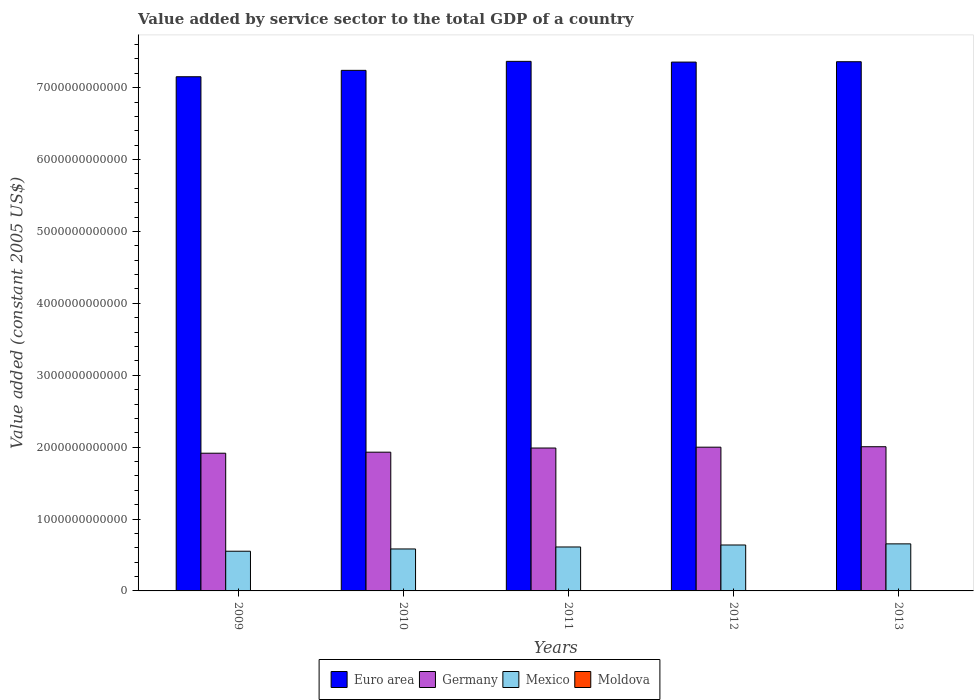How many different coloured bars are there?
Offer a very short reply. 4. How many groups of bars are there?
Your answer should be very brief. 5. How many bars are there on the 3rd tick from the left?
Ensure brevity in your answer.  4. How many bars are there on the 1st tick from the right?
Your response must be concise. 4. What is the value added by service sector in Mexico in 2013?
Keep it short and to the point. 6.54e+11. Across all years, what is the maximum value added by service sector in Germany?
Ensure brevity in your answer.  2.01e+12. Across all years, what is the minimum value added by service sector in Germany?
Offer a terse response. 1.92e+12. In which year was the value added by service sector in Moldova maximum?
Offer a very short reply. 2013. What is the total value added by service sector in Moldova in the graph?
Offer a terse response. 1.70e+1. What is the difference between the value added by service sector in Mexico in 2009 and that in 2011?
Ensure brevity in your answer.  -5.90e+1. What is the difference between the value added by service sector in Germany in 2009 and the value added by service sector in Mexico in 2013?
Keep it short and to the point. 1.26e+12. What is the average value added by service sector in Moldova per year?
Offer a very short reply. 3.40e+09. In the year 2011, what is the difference between the value added by service sector in Germany and value added by service sector in Mexico?
Offer a very short reply. 1.38e+12. What is the ratio of the value added by service sector in Euro area in 2010 to that in 2012?
Ensure brevity in your answer.  0.98. Is the difference between the value added by service sector in Germany in 2009 and 2012 greater than the difference between the value added by service sector in Mexico in 2009 and 2012?
Offer a terse response. Yes. What is the difference between the highest and the second highest value added by service sector in Euro area?
Make the answer very short. 5.09e+09. What is the difference between the highest and the lowest value added by service sector in Euro area?
Provide a succinct answer. 2.14e+11. In how many years, is the value added by service sector in Moldova greater than the average value added by service sector in Moldova taken over all years?
Provide a short and direct response. 3. Is the sum of the value added by service sector in Euro area in 2009 and 2010 greater than the maximum value added by service sector in Mexico across all years?
Provide a succinct answer. Yes. Is it the case that in every year, the sum of the value added by service sector in Mexico and value added by service sector in Moldova is greater than the sum of value added by service sector in Euro area and value added by service sector in Germany?
Your answer should be very brief. No. How many bars are there?
Offer a terse response. 20. Are all the bars in the graph horizontal?
Your response must be concise. No. What is the difference between two consecutive major ticks on the Y-axis?
Ensure brevity in your answer.  1.00e+12. Are the values on the major ticks of Y-axis written in scientific E-notation?
Keep it short and to the point. No. How many legend labels are there?
Your response must be concise. 4. What is the title of the graph?
Your answer should be compact. Value added by service sector to the total GDP of a country. Does "High income: nonOECD" appear as one of the legend labels in the graph?
Your answer should be very brief. No. What is the label or title of the X-axis?
Your answer should be compact. Years. What is the label or title of the Y-axis?
Offer a terse response. Value added (constant 2005 US$). What is the Value added (constant 2005 US$) of Euro area in 2009?
Offer a terse response. 7.15e+12. What is the Value added (constant 2005 US$) of Germany in 2009?
Offer a terse response. 1.92e+12. What is the Value added (constant 2005 US$) in Mexico in 2009?
Your answer should be compact. 5.52e+11. What is the Value added (constant 2005 US$) in Moldova in 2009?
Keep it short and to the point. 3.04e+09. What is the Value added (constant 2005 US$) in Euro area in 2010?
Provide a short and direct response. 7.24e+12. What is the Value added (constant 2005 US$) of Germany in 2010?
Offer a very short reply. 1.93e+12. What is the Value added (constant 2005 US$) in Mexico in 2010?
Your answer should be compact. 5.84e+11. What is the Value added (constant 2005 US$) in Moldova in 2010?
Provide a short and direct response. 3.20e+09. What is the Value added (constant 2005 US$) of Euro area in 2011?
Keep it short and to the point. 7.37e+12. What is the Value added (constant 2005 US$) in Germany in 2011?
Provide a succinct answer. 1.99e+12. What is the Value added (constant 2005 US$) of Mexico in 2011?
Keep it short and to the point. 6.11e+11. What is the Value added (constant 2005 US$) in Moldova in 2011?
Make the answer very short. 3.45e+09. What is the Value added (constant 2005 US$) in Euro area in 2012?
Provide a short and direct response. 7.36e+12. What is the Value added (constant 2005 US$) in Germany in 2012?
Make the answer very short. 2.00e+12. What is the Value added (constant 2005 US$) of Mexico in 2012?
Make the answer very short. 6.39e+11. What is the Value added (constant 2005 US$) of Moldova in 2012?
Make the answer very short. 3.63e+09. What is the Value added (constant 2005 US$) in Euro area in 2013?
Your response must be concise. 7.36e+12. What is the Value added (constant 2005 US$) of Germany in 2013?
Your answer should be very brief. 2.01e+12. What is the Value added (constant 2005 US$) in Mexico in 2013?
Offer a terse response. 6.54e+11. What is the Value added (constant 2005 US$) in Moldova in 2013?
Your answer should be very brief. 3.67e+09. Across all years, what is the maximum Value added (constant 2005 US$) of Euro area?
Make the answer very short. 7.37e+12. Across all years, what is the maximum Value added (constant 2005 US$) in Germany?
Provide a succinct answer. 2.01e+12. Across all years, what is the maximum Value added (constant 2005 US$) in Mexico?
Offer a very short reply. 6.54e+11. Across all years, what is the maximum Value added (constant 2005 US$) of Moldova?
Your answer should be compact. 3.67e+09. Across all years, what is the minimum Value added (constant 2005 US$) of Euro area?
Your answer should be compact. 7.15e+12. Across all years, what is the minimum Value added (constant 2005 US$) of Germany?
Provide a succinct answer. 1.92e+12. Across all years, what is the minimum Value added (constant 2005 US$) in Mexico?
Your answer should be very brief. 5.52e+11. Across all years, what is the minimum Value added (constant 2005 US$) of Moldova?
Ensure brevity in your answer.  3.04e+09. What is the total Value added (constant 2005 US$) in Euro area in the graph?
Keep it short and to the point. 3.65e+13. What is the total Value added (constant 2005 US$) of Germany in the graph?
Keep it short and to the point. 9.84e+12. What is the total Value added (constant 2005 US$) of Mexico in the graph?
Your answer should be very brief. 3.04e+12. What is the total Value added (constant 2005 US$) of Moldova in the graph?
Provide a succinct answer. 1.70e+1. What is the difference between the Value added (constant 2005 US$) of Euro area in 2009 and that in 2010?
Your answer should be very brief. -8.87e+1. What is the difference between the Value added (constant 2005 US$) of Germany in 2009 and that in 2010?
Ensure brevity in your answer.  -1.43e+1. What is the difference between the Value added (constant 2005 US$) of Mexico in 2009 and that in 2010?
Your response must be concise. -3.13e+1. What is the difference between the Value added (constant 2005 US$) in Moldova in 2009 and that in 2010?
Give a very brief answer. -1.55e+08. What is the difference between the Value added (constant 2005 US$) in Euro area in 2009 and that in 2011?
Provide a succinct answer. -2.14e+11. What is the difference between the Value added (constant 2005 US$) of Germany in 2009 and that in 2011?
Give a very brief answer. -7.21e+1. What is the difference between the Value added (constant 2005 US$) of Mexico in 2009 and that in 2011?
Provide a succinct answer. -5.90e+1. What is the difference between the Value added (constant 2005 US$) in Moldova in 2009 and that in 2011?
Offer a terse response. -4.07e+08. What is the difference between the Value added (constant 2005 US$) of Euro area in 2009 and that in 2012?
Your answer should be compact. -2.04e+11. What is the difference between the Value added (constant 2005 US$) in Germany in 2009 and that in 2012?
Provide a short and direct response. -8.38e+1. What is the difference between the Value added (constant 2005 US$) in Mexico in 2009 and that in 2012?
Keep it short and to the point. -8.66e+1. What is the difference between the Value added (constant 2005 US$) of Moldova in 2009 and that in 2012?
Offer a very short reply. -5.87e+08. What is the difference between the Value added (constant 2005 US$) of Euro area in 2009 and that in 2013?
Provide a succinct answer. -2.09e+11. What is the difference between the Value added (constant 2005 US$) of Germany in 2009 and that in 2013?
Ensure brevity in your answer.  -9.01e+1. What is the difference between the Value added (constant 2005 US$) in Mexico in 2009 and that in 2013?
Your response must be concise. -1.02e+11. What is the difference between the Value added (constant 2005 US$) in Moldova in 2009 and that in 2013?
Make the answer very short. -6.29e+08. What is the difference between the Value added (constant 2005 US$) of Euro area in 2010 and that in 2011?
Your response must be concise. -1.25e+11. What is the difference between the Value added (constant 2005 US$) in Germany in 2010 and that in 2011?
Keep it short and to the point. -5.78e+1. What is the difference between the Value added (constant 2005 US$) of Mexico in 2010 and that in 2011?
Keep it short and to the point. -2.77e+1. What is the difference between the Value added (constant 2005 US$) of Moldova in 2010 and that in 2011?
Offer a terse response. -2.52e+08. What is the difference between the Value added (constant 2005 US$) of Euro area in 2010 and that in 2012?
Your response must be concise. -1.15e+11. What is the difference between the Value added (constant 2005 US$) in Germany in 2010 and that in 2012?
Keep it short and to the point. -6.95e+1. What is the difference between the Value added (constant 2005 US$) of Mexico in 2010 and that in 2012?
Your response must be concise. -5.53e+1. What is the difference between the Value added (constant 2005 US$) of Moldova in 2010 and that in 2012?
Your response must be concise. -4.32e+08. What is the difference between the Value added (constant 2005 US$) in Euro area in 2010 and that in 2013?
Your response must be concise. -1.20e+11. What is the difference between the Value added (constant 2005 US$) of Germany in 2010 and that in 2013?
Provide a succinct answer. -7.58e+1. What is the difference between the Value added (constant 2005 US$) in Mexico in 2010 and that in 2013?
Make the answer very short. -7.09e+1. What is the difference between the Value added (constant 2005 US$) of Moldova in 2010 and that in 2013?
Provide a succinct answer. -4.74e+08. What is the difference between the Value added (constant 2005 US$) in Euro area in 2011 and that in 2012?
Provide a short and direct response. 1.02e+1. What is the difference between the Value added (constant 2005 US$) in Germany in 2011 and that in 2012?
Offer a terse response. -1.17e+1. What is the difference between the Value added (constant 2005 US$) in Mexico in 2011 and that in 2012?
Your answer should be very brief. -2.76e+1. What is the difference between the Value added (constant 2005 US$) in Moldova in 2011 and that in 2012?
Offer a terse response. -1.80e+08. What is the difference between the Value added (constant 2005 US$) in Euro area in 2011 and that in 2013?
Provide a succinct answer. 5.09e+09. What is the difference between the Value added (constant 2005 US$) in Germany in 2011 and that in 2013?
Offer a very short reply. -1.80e+1. What is the difference between the Value added (constant 2005 US$) in Mexico in 2011 and that in 2013?
Provide a succinct answer. -4.32e+1. What is the difference between the Value added (constant 2005 US$) of Moldova in 2011 and that in 2013?
Keep it short and to the point. -2.22e+08. What is the difference between the Value added (constant 2005 US$) of Euro area in 2012 and that in 2013?
Your answer should be compact. -5.07e+09. What is the difference between the Value added (constant 2005 US$) of Germany in 2012 and that in 2013?
Your answer should be very brief. -6.36e+09. What is the difference between the Value added (constant 2005 US$) of Mexico in 2012 and that in 2013?
Your response must be concise. -1.56e+1. What is the difference between the Value added (constant 2005 US$) in Moldova in 2012 and that in 2013?
Provide a succinct answer. -4.26e+07. What is the difference between the Value added (constant 2005 US$) of Euro area in 2009 and the Value added (constant 2005 US$) of Germany in 2010?
Your response must be concise. 5.22e+12. What is the difference between the Value added (constant 2005 US$) in Euro area in 2009 and the Value added (constant 2005 US$) in Mexico in 2010?
Give a very brief answer. 6.57e+12. What is the difference between the Value added (constant 2005 US$) of Euro area in 2009 and the Value added (constant 2005 US$) of Moldova in 2010?
Provide a succinct answer. 7.15e+12. What is the difference between the Value added (constant 2005 US$) in Germany in 2009 and the Value added (constant 2005 US$) in Mexico in 2010?
Your answer should be very brief. 1.33e+12. What is the difference between the Value added (constant 2005 US$) in Germany in 2009 and the Value added (constant 2005 US$) in Moldova in 2010?
Provide a succinct answer. 1.91e+12. What is the difference between the Value added (constant 2005 US$) of Mexico in 2009 and the Value added (constant 2005 US$) of Moldova in 2010?
Your response must be concise. 5.49e+11. What is the difference between the Value added (constant 2005 US$) of Euro area in 2009 and the Value added (constant 2005 US$) of Germany in 2011?
Offer a very short reply. 5.16e+12. What is the difference between the Value added (constant 2005 US$) of Euro area in 2009 and the Value added (constant 2005 US$) of Mexico in 2011?
Your answer should be very brief. 6.54e+12. What is the difference between the Value added (constant 2005 US$) in Euro area in 2009 and the Value added (constant 2005 US$) in Moldova in 2011?
Provide a succinct answer. 7.15e+12. What is the difference between the Value added (constant 2005 US$) in Germany in 2009 and the Value added (constant 2005 US$) in Mexico in 2011?
Offer a very short reply. 1.30e+12. What is the difference between the Value added (constant 2005 US$) in Germany in 2009 and the Value added (constant 2005 US$) in Moldova in 2011?
Offer a terse response. 1.91e+12. What is the difference between the Value added (constant 2005 US$) in Mexico in 2009 and the Value added (constant 2005 US$) in Moldova in 2011?
Your answer should be compact. 5.49e+11. What is the difference between the Value added (constant 2005 US$) in Euro area in 2009 and the Value added (constant 2005 US$) in Germany in 2012?
Offer a terse response. 5.15e+12. What is the difference between the Value added (constant 2005 US$) of Euro area in 2009 and the Value added (constant 2005 US$) of Mexico in 2012?
Offer a very short reply. 6.51e+12. What is the difference between the Value added (constant 2005 US$) in Euro area in 2009 and the Value added (constant 2005 US$) in Moldova in 2012?
Give a very brief answer. 7.15e+12. What is the difference between the Value added (constant 2005 US$) in Germany in 2009 and the Value added (constant 2005 US$) in Mexico in 2012?
Provide a succinct answer. 1.28e+12. What is the difference between the Value added (constant 2005 US$) of Germany in 2009 and the Value added (constant 2005 US$) of Moldova in 2012?
Your answer should be compact. 1.91e+12. What is the difference between the Value added (constant 2005 US$) in Mexico in 2009 and the Value added (constant 2005 US$) in Moldova in 2012?
Ensure brevity in your answer.  5.49e+11. What is the difference between the Value added (constant 2005 US$) in Euro area in 2009 and the Value added (constant 2005 US$) in Germany in 2013?
Keep it short and to the point. 5.15e+12. What is the difference between the Value added (constant 2005 US$) in Euro area in 2009 and the Value added (constant 2005 US$) in Mexico in 2013?
Keep it short and to the point. 6.50e+12. What is the difference between the Value added (constant 2005 US$) of Euro area in 2009 and the Value added (constant 2005 US$) of Moldova in 2013?
Provide a succinct answer. 7.15e+12. What is the difference between the Value added (constant 2005 US$) of Germany in 2009 and the Value added (constant 2005 US$) of Mexico in 2013?
Keep it short and to the point. 1.26e+12. What is the difference between the Value added (constant 2005 US$) in Germany in 2009 and the Value added (constant 2005 US$) in Moldova in 2013?
Your answer should be compact. 1.91e+12. What is the difference between the Value added (constant 2005 US$) of Mexico in 2009 and the Value added (constant 2005 US$) of Moldova in 2013?
Your answer should be compact. 5.49e+11. What is the difference between the Value added (constant 2005 US$) of Euro area in 2010 and the Value added (constant 2005 US$) of Germany in 2011?
Make the answer very short. 5.25e+12. What is the difference between the Value added (constant 2005 US$) in Euro area in 2010 and the Value added (constant 2005 US$) in Mexico in 2011?
Give a very brief answer. 6.63e+12. What is the difference between the Value added (constant 2005 US$) in Euro area in 2010 and the Value added (constant 2005 US$) in Moldova in 2011?
Provide a succinct answer. 7.24e+12. What is the difference between the Value added (constant 2005 US$) in Germany in 2010 and the Value added (constant 2005 US$) in Mexico in 2011?
Your answer should be very brief. 1.32e+12. What is the difference between the Value added (constant 2005 US$) in Germany in 2010 and the Value added (constant 2005 US$) in Moldova in 2011?
Provide a succinct answer. 1.93e+12. What is the difference between the Value added (constant 2005 US$) of Mexico in 2010 and the Value added (constant 2005 US$) of Moldova in 2011?
Give a very brief answer. 5.80e+11. What is the difference between the Value added (constant 2005 US$) in Euro area in 2010 and the Value added (constant 2005 US$) in Germany in 2012?
Give a very brief answer. 5.24e+12. What is the difference between the Value added (constant 2005 US$) of Euro area in 2010 and the Value added (constant 2005 US$) of Mexico in 2012?
Ensure brevity in your answer.  6.60e+12. What is the difference between the Value added (constant 2005 US$) of Euro area in 2010 and the Value added (constant 2005 US$) of Moldova in 2012?
Ensure brevity in your answer.  7.24e+12. What is the difference between the Value added (constant 2005 US$) in Germany in 2010 and the Value added (constant 2005 US$) in Mexico in 2012?
Provide a succinct answer. 1.29e+12. What is the difference between the Value added (constant 2005 US$) in Germany in 2010 and the Value added (constant 2005 US$) in Moldova in 2012?
Offer a very short reply. 1.93e+12. What is the difference between the Value added (constant 2005 US$) of Mexico in 2010 and the Value added (constant 2005 US$) of Moldova in 2012?
Make the answer very short. 5.80e+11. What is the difference between the Value added (constant 2005 US$) in Euro area in 2010 and the Value added (constant 2005 US$) in Germany in 2013?
Your answer should be compact. 5.24e+12. What is the difference between the Value added (constant 2005 US$) of Euro area in 2010 and the Value added (constant 2005 US$) of Mexico in 2013?
Your answer should be very brief. 6.59e+12. What is the difference between the Value added (constant 2005 US$) in Euro area in 2010 and the Value added (constant 2005 US$) in Moldova in 2013?
Provide a short and direct response. 7.24e+12. What is the difference between the Value added (constant 2005 US$) in Germany in 2010 and the Value added (constant 2005 US$) in Mexico in 2013?
Your answer should be compact. 1.28e+12. What is the difference between the Value added (constant 2005 US$) in Germany in 2010 and the Value added (constant 2005 US$) in Moldova in 2013?
Give a very brief answer. 1.93e+12. What is the difference between the Value added (constant 2005 US$) of Mexico in 2010 and the Value added (constant 2005 US$) of Moldova in 2013?
Offer a very short reply. 5.80e+11. What is the difference between the Value added (constant 2005 US$) in Euro area in 2011 and the Value added (constant 2005 US$) in Germany in 2012?
Offer a very short reply. 5.37e+12. What is the difference between the Value added (constant 2005 US$) of Euro area in 2011 and the Value added (constant 2005 US$) of Mexico in 2012?
Offer a very short reply. 6.73e+12. What is the difference between the Value added (constant 2005 US$) of Euro area in 2011 and the Value added (constant 2005 US$) of Moldova in 2012?
Offer a terse response. 7.36e+12. What is the difference between the Value added (constant 2005 US$) of Germany in 2011 and the Value added (constant 2005 US$) of Mexico in 2012?
Provide a short and direct response. 1.35e+12. What is the difference between the Value added (constant 2005 US$) in Germany in 2011 and the Value added (constant 2005 US$) in Moldova in 2012?
Offer a terse response. 1.98e+12. What is the difference between the Value added (constant 2005 US$) in Mexico in 2011 and the Value added (constant 2005 US$) in Moldova in 2012?
Provide a succinct answer. 6.08e+11. What is the difference between the Value added (constant 2005 US$) in Euro area in 2011 and the Value added (constant 2005 US$) in Germany in 2013?
Your answer should be compact. 5.36e+12. What is the difference between the Value added (constant 2005 US$) of Euro area in 2011 and the Value added (constant 2005 US$) of Mexico in 2013?
Provide a succinct answer. 6.71e+12. What is the difference between the Value added (constant 2005 US$) of Euro area in 2011 and the Value added (constant 2005 US$) of Moldova in 2013?
Ensure brevity in your answer.  7.36e+12. What is the difference between the Value added (constant 2005 US$) of Germany in 2011 and the Value added (constant 2005 US$) of Mexico in 2013?
Keep it short and to the point. 1.33e+12. What is the difference between the Value added (constant 2005 US$) of Germany in 2011 and the Value added (constant 2005 US$) of Moldova in 2013?
Offer a very short reply. 1.98e+12. What is the difference between the Value added (constant 2005 US$) of Mexico in 2011 and the Value added (constant 2005 US$) of Moldova in 2013?
Keep it short and to the point. 6.08e+11. What is the difference between the Value added (constant 2005 US$) in Euro area in 2012 and the Value added (constant 2005 US$) in Germany in 2013?
Provide a short and direct response. 5.35e+12. What is the difference between the Value added (constant 2005 US$) in Euro area in 2012 and the Value added (constant 2005 US$) in Mexico in 2013?
Ensure brevity in your answer.  6.70e+12. What is the difference between the Value added (constant 2005 US$) in Euro area in 2012 and the Value added (constant 2005 US$) in Moldova in 2013?
Provide a succinct answer. 7.35e+12. What is the difference between the Value added (constant 2005 US$) of Germany in 2012 and the Value added (constant 2005 US$) of Mexico in 2013?
Your response must be concise. 1.34e+12. What is the difference between the Value added (constant 2005 US$) in Germany in 2012 and the Value added (constant 2005 US$) in Moldova in 2013?
Provide a short and direct response. 2.00e+12. What is the difference between the Value added (constant 2005 US$) of Mexico in 2012 and the Value added (constant 2005 US$) of Moldova in 2013?
Make the answer very short. 6.35e+11. What is the average Value added (constant 2005 US$) in Euro area per year?
Provide a succinct answer. 7.30e+12. What is the average Value added (constant 2005 US$) of Germany per year?
Provide a succinct answer. 1.97e+12. What is the average Value added (constant 2005 US$) in Mexico per year?
Keep it short and to the point. 6.08e+11. What is the average Value added (constant 2005 US$) of Moldova per year?
Offer a terse response. 3.40e+09. In the year 2009, what is the difference between the Value added (constant 2005 US$) of Euro area and Value added (constant 2005 US$) of Germany?
Provide a succinct answer. 5.24e+12. In the year 2009, what is the difference between the Value added (constant 2005 US$) of Euro area and Value added (constant 2005 US$) of Mexico?
Give a very brief answer. 6.60e+12. In the year 2009, what is the difference between the Value added (constant 2005 US$) of Euro area and Value added (constant 2005 US$) of Moldova?
Your answer should be very brief. 7.15e+12. In the year 2009, what is the difference between the Value added (constant 2005 US$) of Germany and Value added (constant 2005 US$) of Mexico?
Your response must be concise. 1.36e+12. In the year 2009, what is the difference between the Value added (constant 2005 US$) of Germany and Value added (constant 2005 US$) of Moldova?
Make the answer very short. 1.91e+12. In the year 2009, what is the difference between the Value added (constant 2005 US$) in Mexico and Value added (constant 2005 US$) in Moldova?
Your response must be concise. 5.49e+11. In the year 2010, what is the difference between the Value added (constant 2005 US$) in Euro area and Value added (constant 2005 US$) in Germany?
Provide a short and direct response. 5.31e+12. In the year 2010, what is the difference between the Value added (constant 2005 US$) in Euro area and Value added (constant 2005 US$) in Mexico?
Provide a succinct answer. 6.66e+12. In the year 2010, what is the difference between the Value added (constant 2005 US$) in Euro area and Value added (constant 2005 US$) in Moldova?
Keep it short and to the point. 7.24e+12. In the year 2010, what is the difference between the Value added (constant 2005 US$) of Germany and Value added (constant 2005 US$) of Mexico?
Keep it short and to the point. 1.35e+12. In the year 2010, what is the difference between the Value added (constant 2005 US$) in Germany and Value added (constant 2005 US$) in Moldova?
Provide a succinct answer. 1.93e+12. In the year 2010, what is the difference between the Value added (constant 2005 US$) of Mexico and Value added (constant 2005 US$) of Moldova?
Offer a very short reply. 5.80e+11. In the year 2011, what is the difference between the Value added (constant 2005 US$) in Euro area and Value added (constant 2005 US$) in Germany?
Your response must be concise. 5.38e+12. In the year 2011, what is the difference between the Value added (constant 2005 US$) of Euro area and Value added (constant 2005 US$) of Mexico?
Your answer should be very brief. 6.76e+12. In the year 2011, what is the difference between the Value added (constant 2005 US$) in Euro area and Value added (constant 2005 US$) in Moldova?
Provide a short and direct response. 7.36e+12. In the year 2011, what is the difference between the Value added (constant 2005 US$) in Germany and Value added (constant 2005 US$) in Mexico?
Offer a terse response. 1.38e+12. In the year 2011, what is the difference between the Value added (constant 2005 US$) in Germany and Value added (constant 2005 US$) in Moldova?
Your response must be concise. 1.98e+12. In the year 2011, what is the difference between the Value added (constant 2005 US$) of Mexico and Value added (constant 2005 US$) of Moldova?
Provide a succinct answer. 6.08e+11. In the year 2012, what is the difference between the Value added (constant 2005 US$) of Euro area and Value added (constant 2005 US$) of Germany?
Give a very brief answer. 5.36e+12. In the year 2012, what is the difference between the Value added (constant 2005 US$) in Euro area and Value added (constant 2005 US$) in Mexico?
Give a very brief answer. 6.72e+12. In the year 2012, what is the difference between the Value added (constant 2005 US$) of Euro area and Value added (constant 2005 US$) of Moldova?
Your answer should be compact. 7.35e+12. In the year 2012, what is the difference between the Value added (constant 2005 US$) in Germany and Value added (constant 2005 US$) in Mexico?
Your answer should be compact. 1.36e+12. In the year 2012, what is the difference between the Value added (constant 2005 US$) of Germany and Value added (constant 2005 US$) of Moldova?
Keep it short and to the point. 2.00e+12. In the year 2012, what is the difference between the Value added (constant 2005 US$) of Mexico and Value added (constant 2005 US$) of Moldova?
Make the answer very short. 6.35e+11. In the year 2013, what is the difference between the Value added (constant 2005 US$) of Euro area and Value added (constant 2005 US$) of Germany?
Your response must be concise. 5.36e+12. In the year 2013, what is the difference between the Value added (constant 2005 US$) in Euro area and Value added (constant 2005 US$) in Mexico?
Offer a very short reply. 6.71e+12. In the year 2013, what is the difference between the Value added (constant 2005 US$) of Euro area and Value added (constant 2005 US$) of Moldova?
Make the answer very short. 7.36e+12. In the year 2013, what is the difference between the Value added (constant 2005 US$) in Germany and Value added (constant 2005 US$) in Mexico?
Give a very brief answer. 1.35e+12. In the year 2013, what is the difference between the Value added (constant 2005 US$) of Germany and Value added (constant 2005 US$) of Moldova?
Keep it short and to the point. 2.00e+12. In the year 2013, what is the difference between the Value added (constant 2005 US$) of Mexico and Value added (constant 2005 US$) of Moldova?
Provide a short and direct response. 6.51e+11. What is the ratio of the Value added (constant 2005 US$) of Euro area in 2009 to that in 2010?
Ensure brevity in your answer.  0.99. What is the ratio of the Value added (constant 2005 US$) in Germany in 2009 to that in 2010?
Provide a short and direct response. 0.99. What is the ratio of the Value added (constant 2005 US$) in Mexico in 2009 to that in 2010?
Ensure brevity in your answer.  0.95. What is the ratio of the Value added (constant 2005 US$) of Moldova in 2009 to that in 2010?
Your answer should be very brief. 0.95. What is the ratio of the Value added (constant 2005 US$) in Euro area in 2009 to that in 2011?
Give a very brief answer. 0.97. What is the ratio of the Value added (constant 2005 US$) in Germany in 2009 to that in 2011?
Keep it short and to the point. 0.96. What is the ratio of the Value added (constant 2005 US$) in Mexico in 2009 to that in 2011?
Offer a terse response. 0.9. What is the ratio of the Value added (constant 2005 US$) of Moldova in 2009 to that in 2011?
Your answer should be compact. 0.88. What is the ratio of the Value added (constant 2005 US$) of Euro area in 2009 to that in 2012?
Ensure brevity in your answer.  0.97. What is the ratio of the Value added (constant 2005 US$) of Germany in 2009 to that in 2012?
Offer a terse response. 0.96. What is the ratio of the Value added (constant 2005 US$) of Mexico in 2009 to that in 2012?
Your response must be concise. 0.86. What is the ratio of the Value added (constant 2005 US$) in Moldova in 2009 to that in 2012?
Give a very brief answer. 0.84. What is the ratio of the Value added (constant 2005 US$) of Euro area in 2009 to that in 2013?
Offer a very short reply. 0.97. What is the ratio of the Value added (constant 2005 US$) in Germany in 2009 to that in 2013?
Provide a succinct answer. 0.96. What is the ratio of the Value added (constant 2005 US$) in Mexico in 2009 to that in 2013?
Offer a very short reply. 0.84. What is the ratio of the Value added (constant 2005 US$) of Moldova in 2009 to that in 2013?
Ensure brevity in your answer.  0.83. What is the ratio of the Value added (constant 2005 US$) of Euro area in 2010 to that in 2011?
Your answer should be very brief. 0.98. What is the ratio of the Value added (constant 2005 US$) of Germany in 2010 to that in 2011?
Keep it short and to the point. 0.97. What is the ratio of the Value added (constant 2005 US$) in Mexico in 2010 to that in 2011?
Ensure brevity in your answer.  0.95. What is the ratio of the Value added (constant 2005 US$) of Moldova in 2010 to that in 2011?
Make the answer very short. 0.93. What is the ratio of the Value added (constant 2005 US$) in Euro area in 2010 to that in 2012?
Ensure brevity in your answer.  0.98. What is the ratio of the Value added (constant 2005 US$) in Germany in 2010 to that in 2012?
Keep it short and to the point. 0.97. What is the ratio of the Value added (constant 2005 US$) of Mexico in 2010 to that in 2012?
Keep it short and to the point. 0.91. What is the ratio of the Value added (constant 2005 US$) in Moldova in 2010 to that in 2012?
Ensure brevity in your answer.  0.88. What is the ratio of the Value added (constant 2005 US$) in Euro area in 2010 to that in 2013?
Your answer should be compact. 0.98. What is the ratio of the Value added (constant 2005 US$) in Germany in 2010 to that in 2013?
Ensure brevity in your answer.  0.96. What is the ratio of the Value added (constant 2005 US$) of Mexico in 2010 to that in 2013?
Your answer should be compact. 0.89. What is the ratio of the Value added (constant 2005 US$) in Moldova in 2010 to that in 2013?
Your answer should be compact. 0.87. What is the ratio of the Value added (constant 2005 US$) of Euro area in 2011 to that in 2012?
Your answer should be compact. 1. What is the ratio of the Value added (constant 2005 US$) in Germany in 2011 to that in 2012?
Keep it short and to the point. 0.99. What is the ratio of the Value added (constant 2005 US$) in Mexico in 2011 to that in 2012?
Keep it short and to the point. 0.96. What is the ratio of the Value added (constant 2005 US$) of Moldova in 2011 to that in 2012?
Keep it short and to the point. 0.95. What is the ratio of the Value added (constant 2005 US$) of Germany in 2011 to that in 2013?
Your answer should be compact. 0.99. What is the ratio of the Value added (constant 2005 US$) in Mexico in 2011 to that in 2013?
Ensure brevity in your answer.  0.93. What is the ratio of the Value added (constant 2005 US$) in Moldova in 2011 to that in 2013?
Your answer should be compact. 0.94. What is the ratio of the Value added (constant 2005 US$) of Germany in 2012 to that in 2013?
Provide a succinct answer. 1. What is the ratio of the Value added (constant 2005 US$) of Mexico in 2012 to that in 2013?
Your answer should be compact. 0.98. What is the ratio of the Value added (constant 2005 US$) of Moldova in 2012 to that in 2013?
Give a very brief answer. 0.99. What is the difference between the highest and the second highest Value added (constant 2005 US$) in Euro area?
Ensure brevity in your answer.  5.09e+09. What is the difference between the highest and the second highest Value added (constant 2005 US$) in Germany?
Ensure brevity in your answer.  6.36e+09. What is the difference between the highest and the second highest Value added (constant 2005 US$) in Mexico?
Offer a terse response. 1.56e+1. What is the difference between the highest and the second highest Value added (constant 2005 US$) of Moldova?
Ensure brevity in your answer.  4.26e+07. What is the difference between the highest and the lowest Value added (constant 2005 US$) of Euro area?
Your response must be concise. 2.14e+11. What is the difference between the highest and the lowest Value added (constant 2005 US$) in Germany?
Make the answer very short. 9.01e+1. What is the difference between the highest and the lowest Value added (constant 2005 US$) of Mexico?
Offer a very short reply. 1.02e+11. What is the difference between the highest and the lowest Value added (constant 2005 US$) of Moldova?
Your response must be concise. 6.29e+08. 